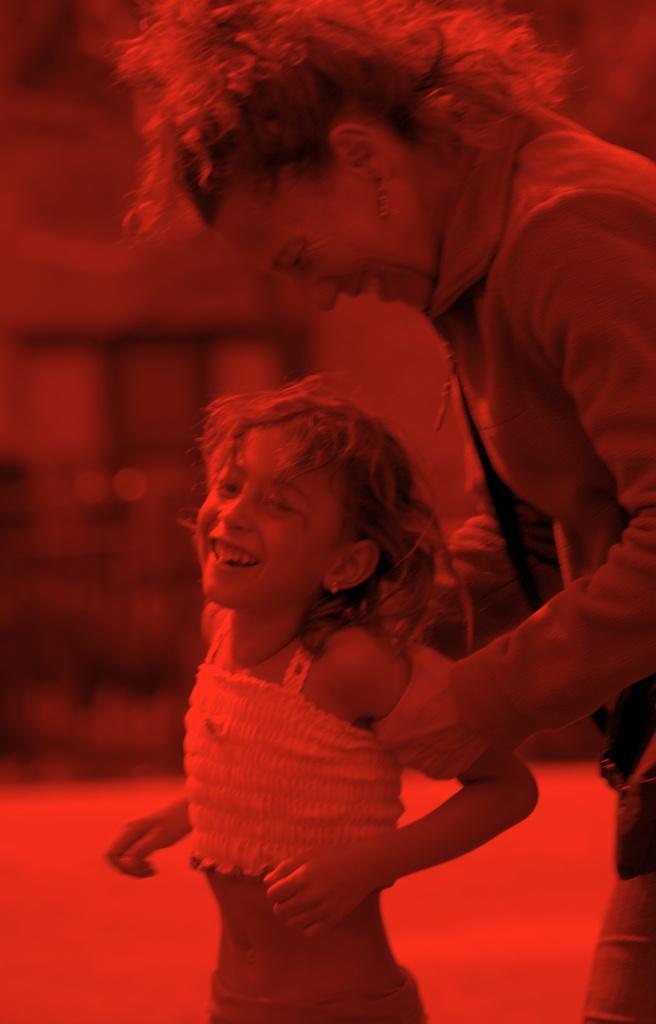Describe this image in one or two sentences. In this picture there is a woman and a kid. This is an edited picture. The background is blurred. 